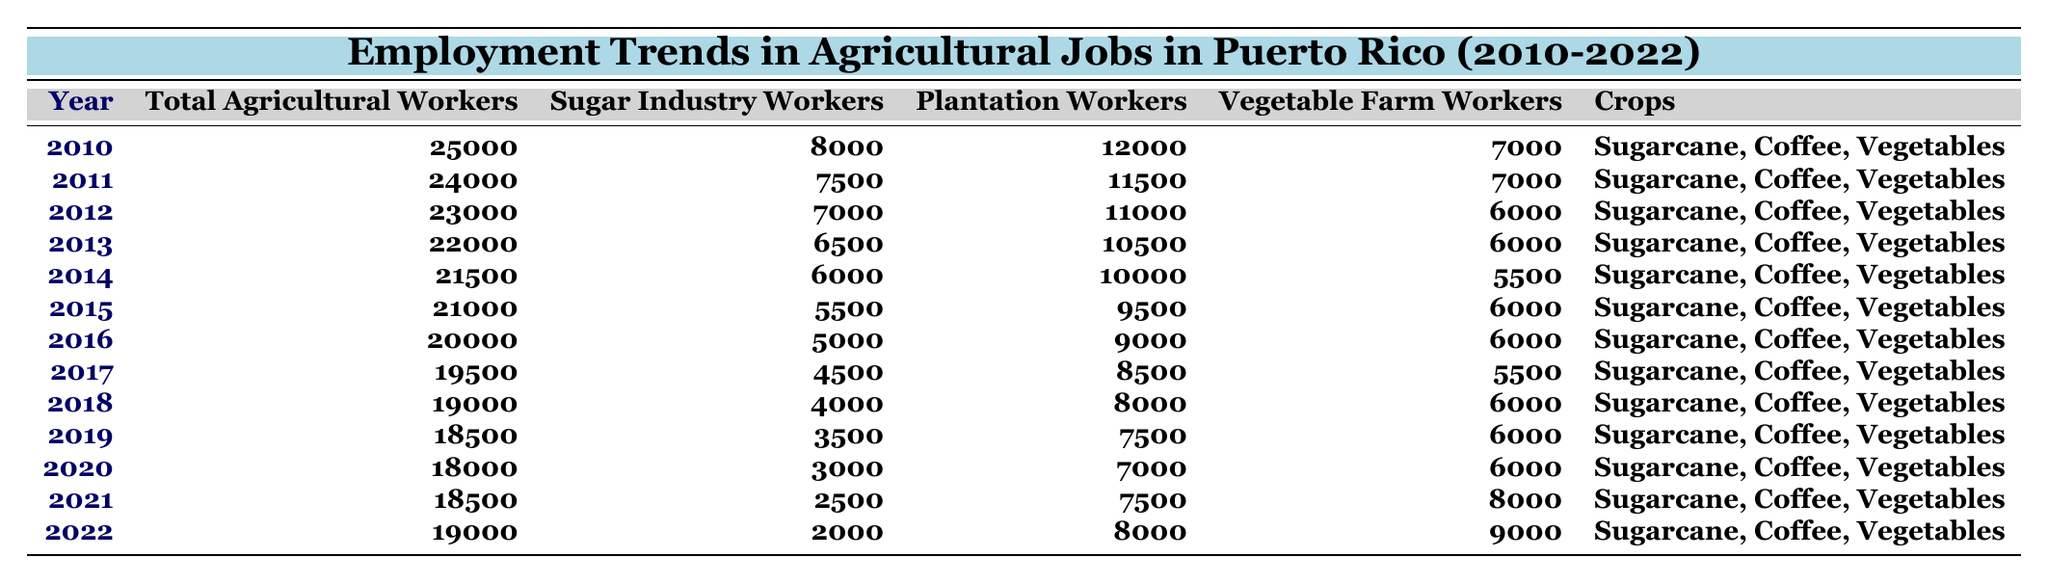What was the year with the highest number of total agricultural workers? The highest number of total agricultural workers in the table is 25,000, which occurred in the year 2010.
Answer: 2010 How many sugar industry workers were there in 2015? According to the table, there were 5,500 sugar industry workers in 2015.
Answer: 5500 What is the total number of vegetable farm workers in 2022 compared to 2010? In 2022, there were 9,000 vegetable farm workers and in 2010, there were 7,000. The difference is 9,000 - 7,000 = 2,000.
Answer: 2000 Was there an increase in the total number of agricultural workers from 2021 to 2022? In 2021, there were 18,500 agricultural workers, and in 2022, there were 19,000. Since 19,000 is greater than 18,500, there was an increase.
Answer: Yes What was the percentage decrease in sugar industry workers from 2010 to 2020? The number of sugar industry workers dropped from 8,000 in 2010 to 3,000 in 2020. The decrease is 8,000 - 3,000 = 5,000. The percentage decrease is (5,000/8,000) * 100 = 62.5%.
Answer: 62.5% How many total agricultural workers were lost from 2010 to 2019? In 2010, there were 25,000 total agricultural workers, and in 2019 there were 18,500. The loss is 25,000 - 18,500 = 6,500.
Answer: 6500 In which year did plantation workers reach the highest count? The highest number of plantation workers occurred in 2010 with 12,000 workers.
Answer: 2010 Looking at the years, did the sugar industry workers ever exceed 8,000 after 2010? After 2010, the highest value for sugar industry workers was in 2011 with 7,500, which is less than 8,000. Therefore, it never exceeded 8,000 after 2010.
Answer: No What was the average number of vegetable farm workers from 2010 to 2022? Adding the vegetable farm workers from each year gives: 7,000 + 7,000 + 6,000 + 6,000 + 5,500 + 6,000 + 6,000 + 5,500 + 6,000 + 6,000 + 8,000 + 9,000 = 68,000. Dividing by 13 years gives an average of 68,000/13 ≈ 5,230.77.
Answer: Approximately 5231 What trend can be observed regarding total agricultural workers from 2010 to 2022? The number of total agricultural workers showed a consistent decline overall from 2010 to 2020, with a slight increase from 2021 to 2022.
Answer: Decline, slight increase in 2022 